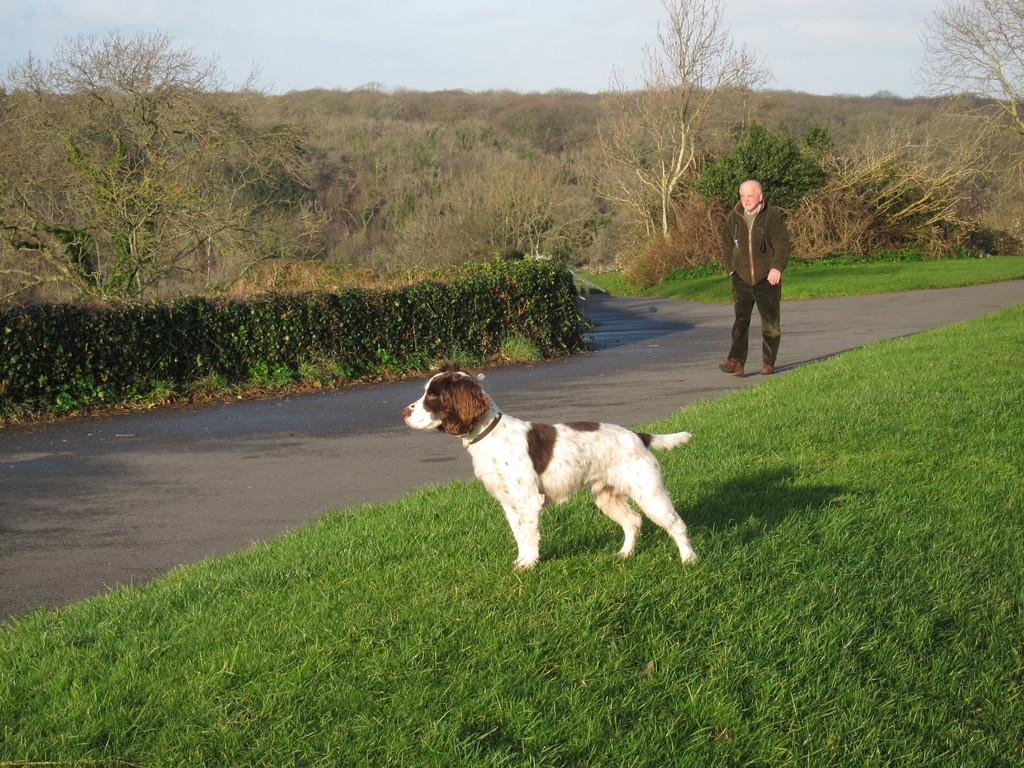In one or two sentences, can you explain what this image depicts? In this picture we can see a dog on the grass and a man walking on the road. In the background we can see trees, plants and the sky. 